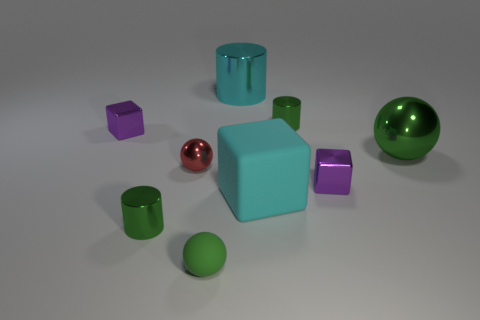Add 1 shiny cylinders. How many objects exist? 10 Subtract all cyan metallic cylinders. How many cylinders are left? 2 Subtract all cylinders. How many objects are left? 6 Subtract 1 cylinders. How many cylinders are left? 2 Subtract all purple balls. How many green cylinders are left? 2 Subtract all small gray cylinders. Subtract all cyan shiny cylinders. How many objects are left? 8 Add 4 purple objects. How many purple objects are left? 6 Add 8 large shiny cylinders. How many large shiny cylinders exist? 9 Subtract all red spheres. How many spheres are left? 2 Subtract 0 purple spheres. How many objects are left? 9 